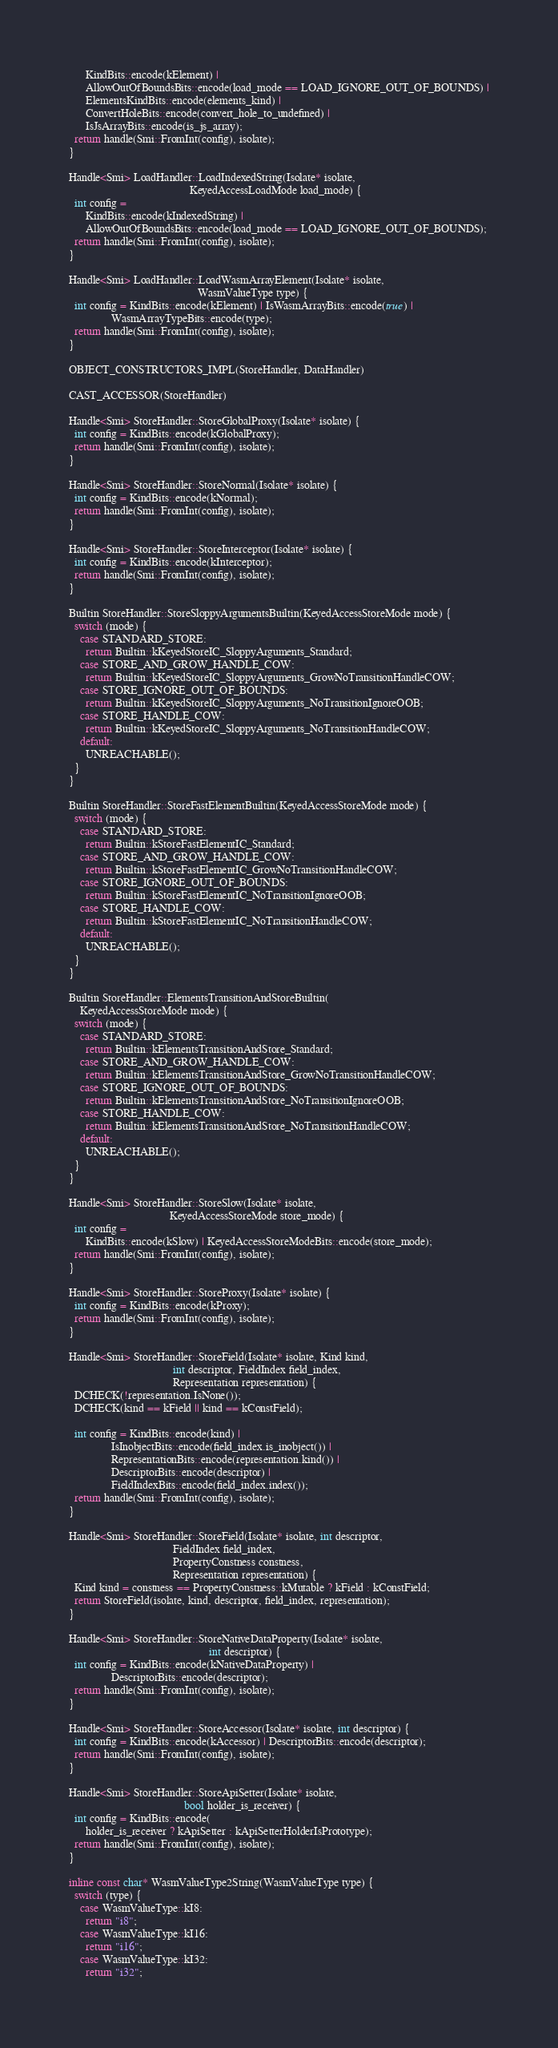<code> <loc_0><loc_0><loc_500><loc_500><_C_>      KindBits::encode(kElement) |
      AllowOutOfBoundsBits::encode(load_mode == LOAD_IGNORE_OUT_OF_BOUNDS) |
      ElementsKindBits::encode(elements_kind) |
      ConvertHoleBits::encode(convert_hole_to_undefined) |
      IsJsArrayBits::encode(is_js_array);
  return handle(Smi::FromInt(config), isolate);
}

Handle<Smi> LoadHandler::LoadIndexedString(Isolate* isolate,
                                           KeyedAccessLoadMode load_mode) {
  int config =
      KindBits::encode(kIndexedString) |
      AllowOutOfBoundsBits::encode(load_mode == LOAD_IGNORE_OUT_OF_BOUNDS);
  return handle(Smi::FromInt(config), isolate);
}

Handle<Smi> LoadHandler::LoadWasmArrayElement(Isolate* isolate,
                                              WasmValueType type) {
  int config = KindBits::encode(kElement) | IsWasmArrayBits::encode(true) |
               WasmArrayTypeBits::encode(type);
  return handle(Smi::FromInt(config), isolate);
}

OBJECT_CONSTRUCTORS_IMPL(StoreHandler, DataHandler)

CAST_ACCESSOR(StoreHandler)

Handle<Smi> StoreHandler::StoreGlobalProxy(Isolate* isolate) {
  int config = KindBits::encode(kGlobalProxy);
  return handle(Smi::FromInt(config), isolate);
}

Handle<Smi> StoreHandler::StoreNormal(Isolate* isolate) {
  int config = KindBits::encode(kNormal);
  return handle(Smi::FromInt(config), isolate);
}

Handle<Smi> StoreHandler::StoreInterceptor(Isolate* isolate) {
  int config = KindBits::encode(kInterceptor);
  return handle(Smi::FromInt(config), isolate);
}

Builtin StoreHandler::StoreSloppyArgumentsBuiltin(KeyedAccessStoreMode mode) {
  switch (mode) {
    case STANDARD_STORE:
      return Builtin::kKeyedStoreIC_SloppyArguments_Standard;
    case STORE_AND_GROW_HANDLE_COW:
      return Builtin::kKeyedStoreIC_SloppyArguments_GrowNoTransitionHandleCOW;
    case STORE_IGNORE_OUT_OF_BOUNDS:
      return Builtin::kKeyedStoreIC_SloppyArguments_NoTransitionIgnoreOOB;
    case STORE_HANDLE_COW:
      return Builtin::kKeyedStoreIC_SloppyArguments_NoTransitionHandleCOW;
    default:
      UNREACHABLE();
  }
}

Builtin StoreHandler::StoreFastElementBuiltin(KeyedAccessStoreMode mode) {
  switch (mode) {
    case STANDARD_STORE:
      return Builtin::kStoreFastElementIC_Standard;
    case STORE_AND_GROW_HANDLE_COW:
      return Builtin::kStoreFastElementIC_GrowNoTransitionHandleCOW;
    case STORE_IGNORE_OUT_OF_BOUNDS:
      return Builtin::kStoreFastElementIC_NoTransitionIgnoreOOB;
    case STORE_HANDLE_COW:
      return Builtin::kStoreFastElementIC_NoTransitionHandleCOW;
    default:
      UNREACHABLE();
  }
}

Builtin StoreHandler::ElementsTransitionAndStoreBuiltin(
    KeyedAccessStoreMode mode) {
  switch (mode) {
    case STANDARD_STORE:
      return Builtin::kElementsTransitionAndStore_Standard;
    case STORE_AND_GROW_HANDLE_COW:
      return Builtin::kElementsTransitionAndStore_GrowNoTransitionHandleCOW;
    case STORE_IGNORE_OUT_OF_BOUNDS:
      return Builtin::kElementsTransitionAndStore_NoTransitionIgnoreOOB;
    case STORE_HANDLE_COW:
      return Builtin::kElementsTransitionAndStore_NoTransitionHandleCOW;
    default:
      UNREACHABLE();
  }
}

Handle<Smi> StoreHandler::StoreSlow(Isolate* isolate,
                                    KeyedAccessStoreMode store_mode) {
  int config =
      KindBits::encode(kSlow) | KeyedAccessStoreModeBits::encode(store_mode);
  return handle(Smi::FromInt(config), isolate);
}

Handle<Smi> StoreHandler::StoreProxy(Isolate* isolate) {
  int config = KindBits::encode(kProxy);
  return handle(Smi::FromInt(config), isolate);
}

Handle<Smi> StoreHandler::StoreField(Isolate* isolate, Kind kind,
                                     int descriptor, FieldIndex field_index,
                                     Representation representation) {
  DCHECK(!representation.IsNone());
  DCHECK(kind == kField || kind == kConstField);

  int config = KindBits::encode(kind) |
               IsInobjectBits::encode(field_index.is_inobject()) |
               RepresentationBits::encode(representation.kind()) |
               DescriptorBits::encode(descriptor) |
               FieldIndexBits::encode(field_index.index());
  return handle(Smi::FromInt(config), isolate);
}

Handle<Smi> StoreHandler::StoreField(Isolate* isolate, int descriptor,
                                     FieldIndex field_index,
                                     PropertyConstness constness,
                                     Representation representation) {
  Kind kind = constness == PropertyConstness::kMutable ? kField : kConstField;
  return StoreField(isolate, kind, descriptor, field_index, representation);
}

Handle<Smi> StoreHandler::StoreNativeDataProperty(Isolate* isolate,
                                                  int descriptor) {
  int config = KindBits::encode(kNativeDataProperty) |
               DescriptorBits::encode(descriptor);
  return handle(Smi::FromInt(config), isolate);
}

Handle<Smi> StoreHandler::StoreAccessor(Isolate* isolate, int descriptor) {
  int config = KindBits::encode(kAccessor) | DescriptorBits::encode(descriptor);
  return handle(Smi::FromInt(config), isolate);
}

Handle<Smi> StoreHandler::StoreApiSetter(Isolate* isolate,
                                         bool holder_is_receiver) {
  int config = KindBits::encode(
      holder_is_receiver ? kApiSetter : kApiSetterHolderIsPrototype);
  return handle(Smi::FromInt(config), isolate);
}

inline const char* WasmValueType2String(WasmValueType type) {
  switch (type) {
    case WasmValueType::kI8:
      return "i8";
    case WasmValueType::kI16:
      return "i16";
    case WasmValueType::kI32:
      return "i32";</code> 